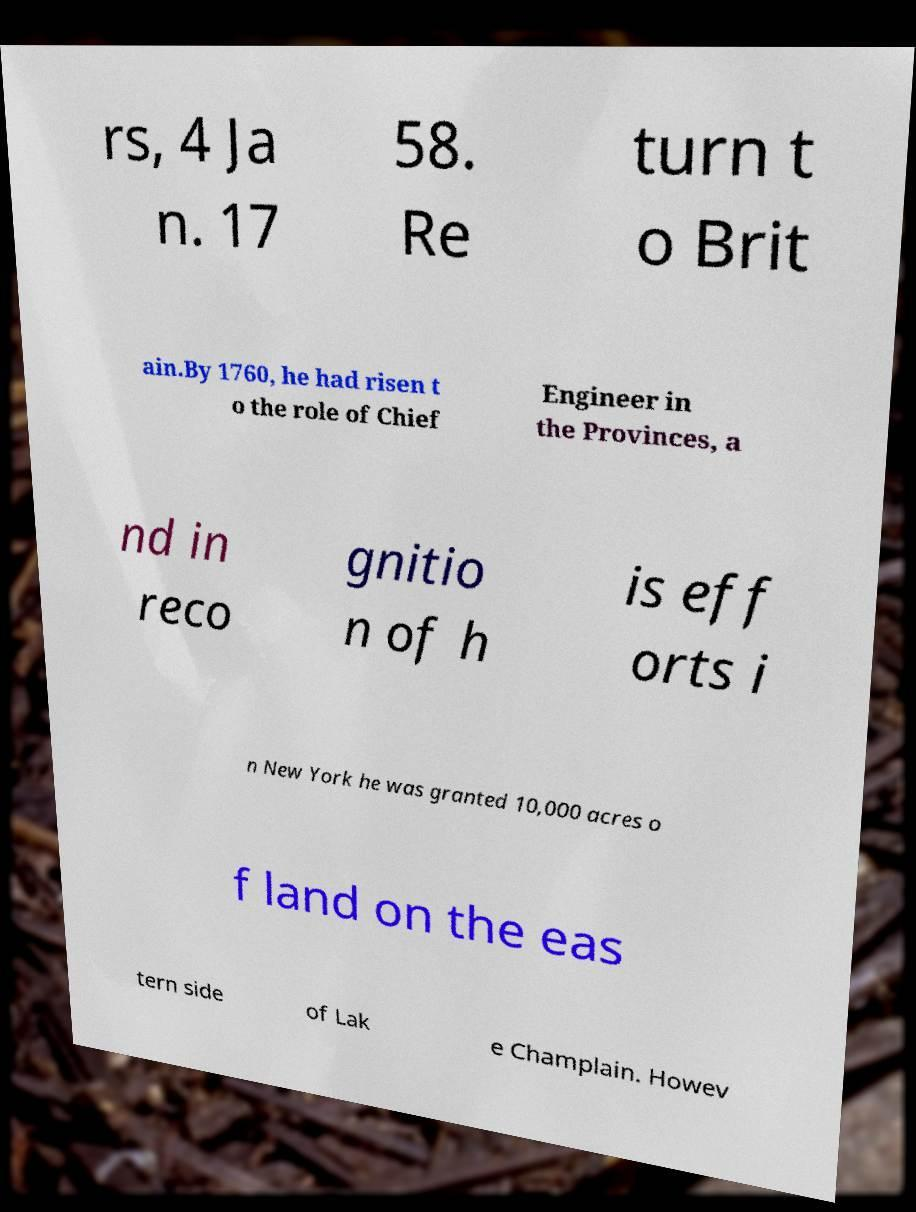What messages or text are displayed in this image? I need them in a readable, typed format. rs, 4 Ja n. 17 58. Re turn t o Brit ain.By 1760, he had risen t o the role of Chief Engineer in the Provinces, a nd in reco gnitio n of h is eff orts i n New York he was granted 10,000 acres o f land on the eas tern side of Lak e Champlain. Howev 